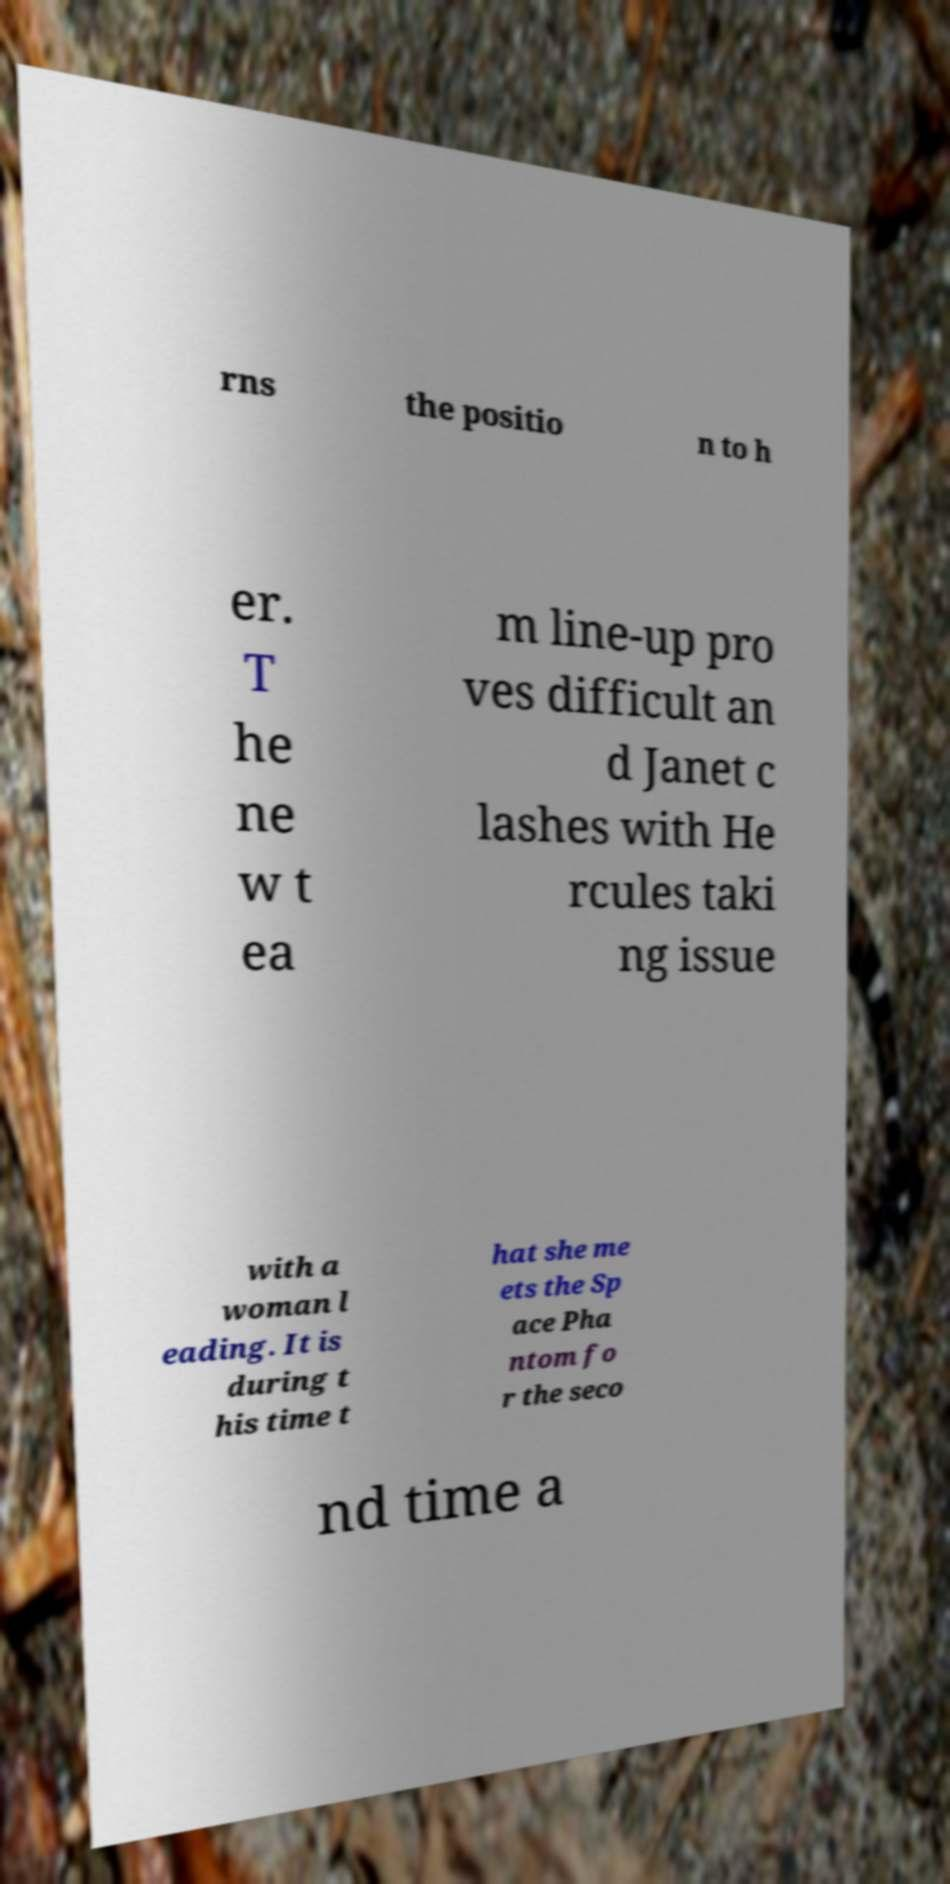Please identify and transcribe the text found in this image. rns the positio n to h er. T he ne w t ea m line-up pro ves difficult an d Janet c lashes with He rcules taki ng issue with a woman l eading. It is during t his time t hat she me ets the Sp ace Pha ntom fo r the seco nd time a 